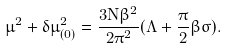<formula> <loc_0><loc_0><loc_500><loc_500>\mu ^ { 2 } + \delta \mu _ { ( 0 ) } ^ { 2 } = \frac { 3 N \beta ^ { 2 } } { 2 \pi ^ { 2 } } ( \Lambda + \frac { \pi } { 2 } \beta \sigma ) .</formula> 